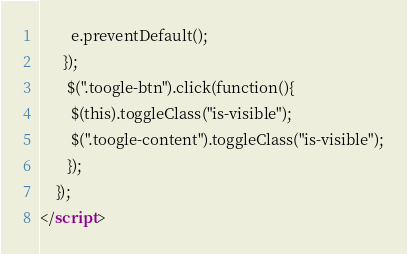Convert code to text. <code><loc_0><loc_0><loc_500><loc_500><_HTML_>	    e.preventDefault();
	  });
	   $(".toogle-btn").click(function(){
        $(this).toggleClass("is-visible");
        $(".toogle-content").toggleClass("is-visible");
       });
	});
</script>


</code> 